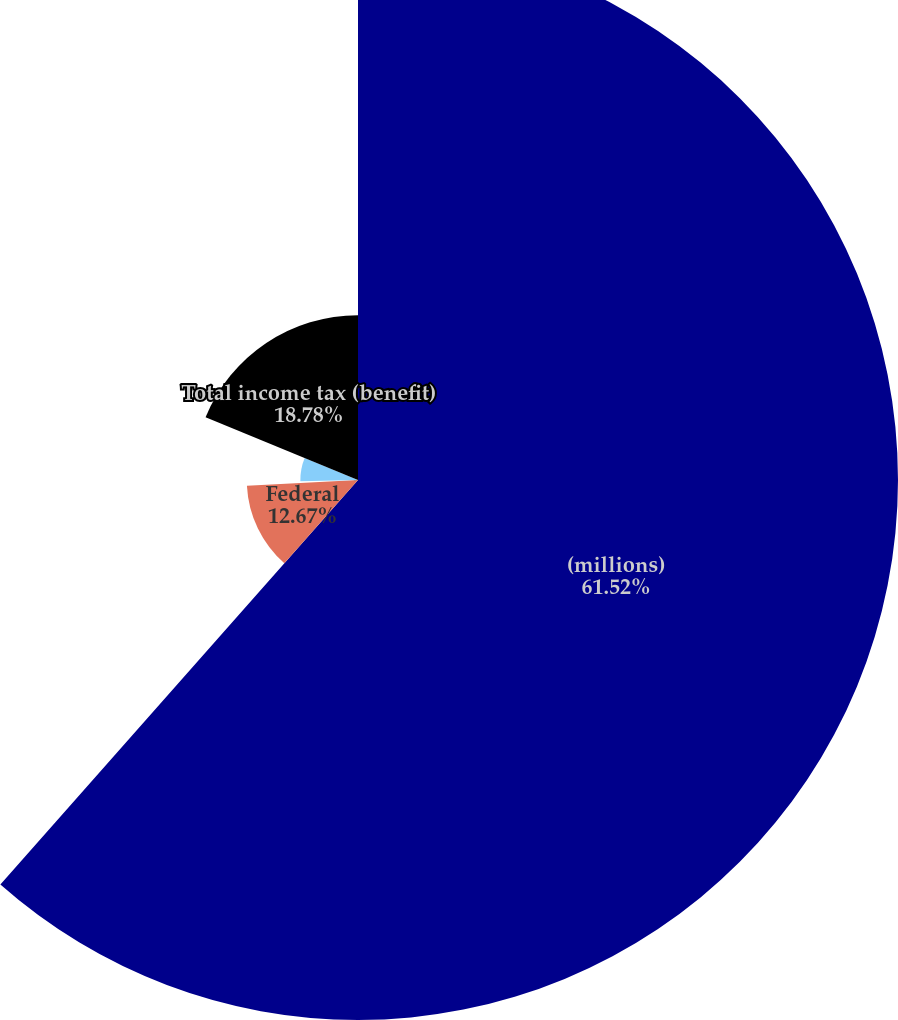<chart> <loc_0><loc_0><loc_500><loc_500><pie_chart><fcel>(millions)<fcel>Federal<fcel>State<fcel>International<fcel>Total income tax (benefit)<nl><fcel>61.52%<fcel>12.67%<fcel>0.46%<fcel>6.57%<fcel>18.78%<nl></chart> 